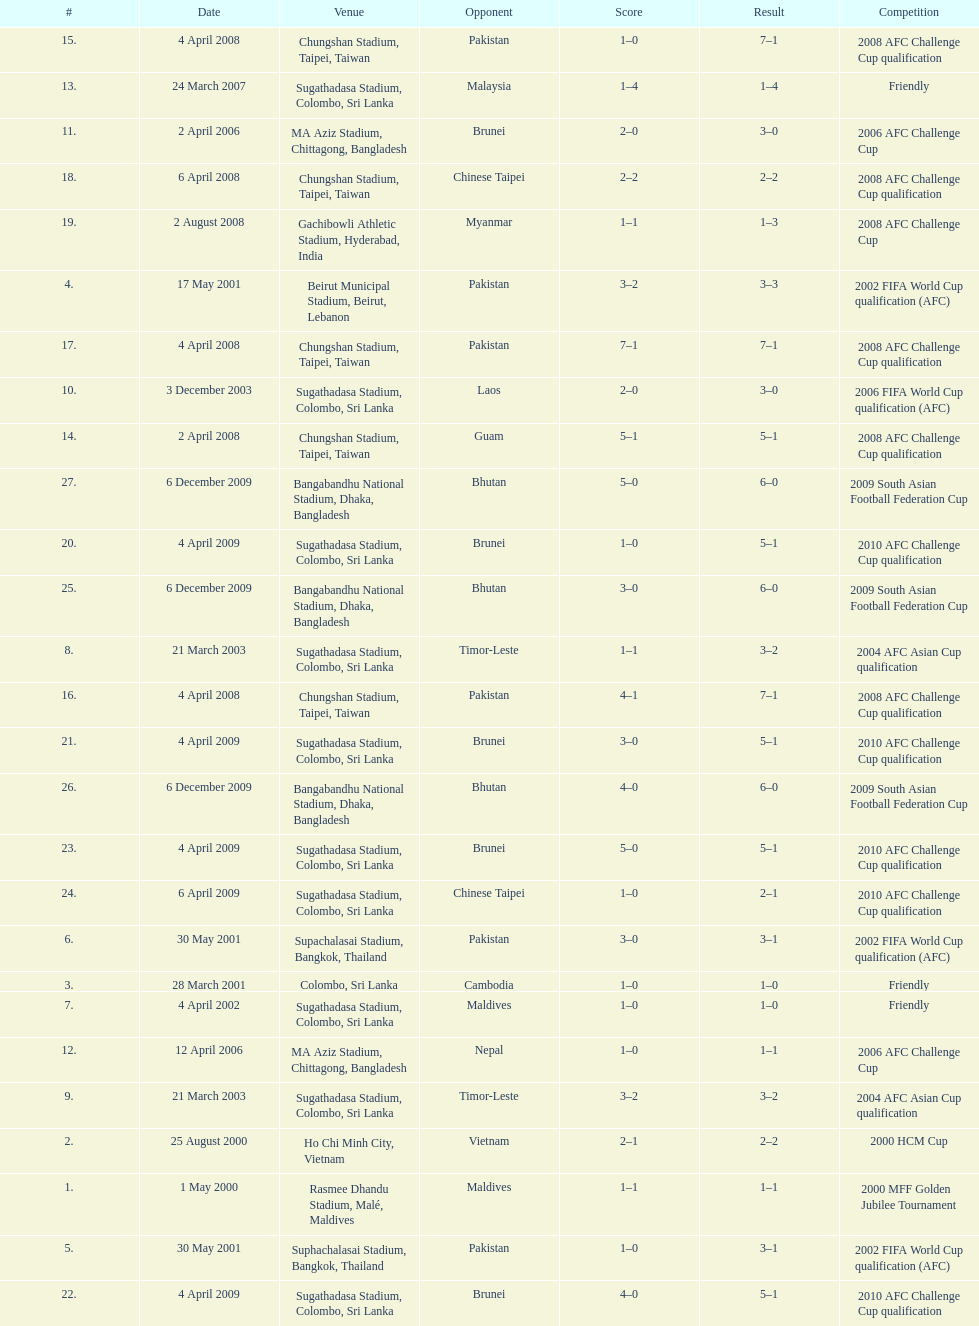What was the total number of goals score in the sri lanka - malaysia game of march 24, 2007? 5. I'm looking to parse the entire table for insights. Could you assist me with that? {'header': ['#', 'Date', 'Venue', 'Opponent', 'Score', 'Result', 'Competition'], 'rows': [['15.', '4 April 2008', 'Chungshan Stadium, Taipei, Taiwan', 'Pakistan', '1–0', '7–1', '2008 AFC Challenge Cup qualification'], ['13.', '24 March 2007', 'Sugathadasa Stadium, Colombo, Sri Lanka', 'Malaysia', '1–4', '1–4', 'Friendly'], ['11.', '2 April 2006', 'MA Aziz Stadium, Chittagong, Bangladesh', 'Brunei', '2–0', '3–0', '2006 AFC Challenge Cup'], ['18.', '6 April 2008', 'Chungshan Stadium, Taipei, Taiwan', 'Chinese Taipei', '2–2', '2–2', '2008 AFC Challenge Cup qualification'], ['19.', '2 August 2008', 'Gachibowli Athletic Stadium, Hyderabad, India', 'Myanmar', '1–1', '1–3', '2008 AFC Challenge Cup'], ['4.', '17 May 2001', 'Beirut Municipal Stadium, Beirut, Lebanon', 'Pakistan', '3–2', '3–3', '2002 FIFA World Cup qualification (AFC)'], ['17.', '4 April 2008', 'Chungshan Stadium, Taipei, Taiwan', 'Pakistan', '7–1', '7–1', '2008 AFC Challenge Cup qualification'], ['10.', '3 December 2003', 'Sugathadasa Stadium, Colombo, Sri Lanka', 'Laos', '2–0', '3–0', '2006 FIFA World Cup qualification (AFC)'], ['14.', '2 April 2008', 'Chungshan Stadium, Taipei, Taiwan', 'Guam', '5–1', '5–1', '2008 AFC Challenge Cup qualification'], ['27.', '6 December 2009', 'Bangabandhu National Stadium, Dhaka, Bangladesh', 'Bhutan', '5–0', '6–0', '2009 South Asian Football Federation Cup'], ['20.', '4 April 2009', 'Sugathadasa Stadium, Colombo, Sri Lanka', 'Brunei', '1–0', '5–1', '2010 AFC Challenge Cup qualification'], ['25.', '6 December 2009', 'Bangabandhu National Stadium, Dhaka, Bangladesh', 'Bhutan', '3–0', '6–0', '2009 South Asian Football Federation Cup'], ['8.', '21 March 2003', 'Sugathadasa Stadium, Colombo, Sri Lanka', 'Timor-Leste', '1–1', '3–2', '2004 AFC Asian Cup qualification'], ['16.', '4 April 2008', 'Chungshan Stadium, Taipei, Taiwan', 'Pakistan', '4–1', '7–1', '2008 AFC Challenge Cup qualification'], ['21.', '4 April 2009', 'Sugathadasa Stadium, Colombo, Sri Lanka', 'Brunei', '3–0', '5–1', '2010 AFC Challenge Cup qualification'], ['26.', '6 December 2009', 'Bangabandhu National Stadium, Dhaka, Bangladesh', 'Bhutan', '4–0', '6–0', '2009 South Asian Football Federation Cup'], ['23.', '4 April 2009', 'Sugathadasa Stadium, Colombo, Sri Lanka', 'Brunei', '5–0', '5–1', '2010 AFC Challenge Cup qualification'], ['24.', '6 April 2009', 'Sugathadasa Stadium, Colombo, Sri Lanka', 'Chinese Taipei', '1–0', '2–1', '2010 AFC Challenge Cup qualification'], ['6.', '30 May 2001', 'Supachalasai Stadium, Bangkok, Thailand', 'Pakistan', '3–0', '3–1', '2002 FIFA World Cup qualification (AFC)'], ['3.', '28 March 2001', 'Colombo, Sri Lanka', 'Cambodia', '1–0', '1–0', 'Friendly'], ['7.', '4 April 2002', 'Sugathadasa Stadium, Colombo, Sri Lanka', 'Maldives', '1–0', '1–0', 'Friendly'], ['12.', '12 April 2006', 'MA Aziz Stadium, Chittagong, Bangladesh', 'Nepal', '1–0', '1–1', '2006 AFC Challenge Cup'], ['9.', '21 March 2003', 'Sugathadasa Stadium, Colombo, Sri Lanka', 'Timor-Leste', '3–2', '3–2', '2004 AFC Asian Cup qualification'], ['2.', '25 August 2000', 'Ho Chi Minh City, Vietnam', 'Vietnam', '2–1', '2–2', '2000 HCM Cup'], ['1.', '1 May 2000', 'Rasmee Dhandu Stadium, Malé, Maldives', 'Maldives', '1–1', '1–1', '2000 MFF Golden Jubilee Tournament'], ['5.', '30 May 2001', 'Suphachalasai Stadium, Bangkok, Thailand', 'Pakistan', '1–0', '3–1', '2002 FIFA World Cup qualification (AFC)'], ['22.', '4 April 2009', 'Sugathadasa Stadium, Colombo, Sri Lanka', 'Brunei', '4–0', '5–1', '2010 AFC Challenge Cup qualification']]} 